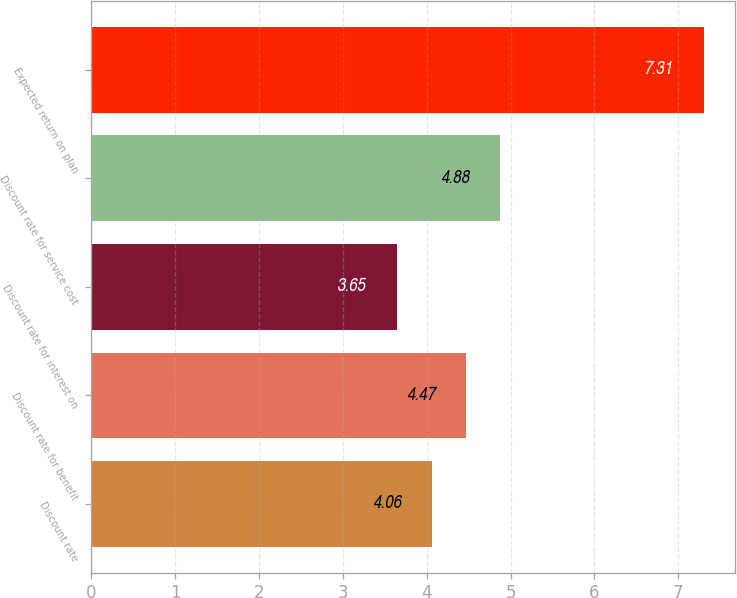Convert chart to OTSL. <chart><loc_0><loc_0><loc_500><loc_500><bar_chart><fcel>Discount rate<fcel>Discount rate for benefit<fcel>Discount rate for interest on<fcel>Discount rate for service cost<fcel>Expected return on plan<nl><fcel>4.06<fcel>4.47<fcel>3.65<fcel>4.88<fcel>7.31<nl></chart> 